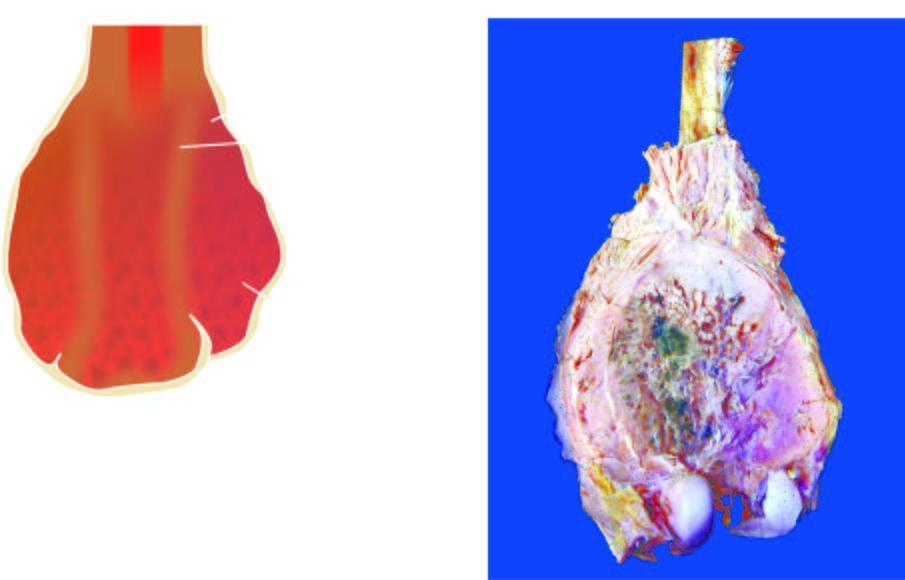s periphery grey-white with areas of haemorrhage and necrosis?
Answer the question using a single word or phrase. No 